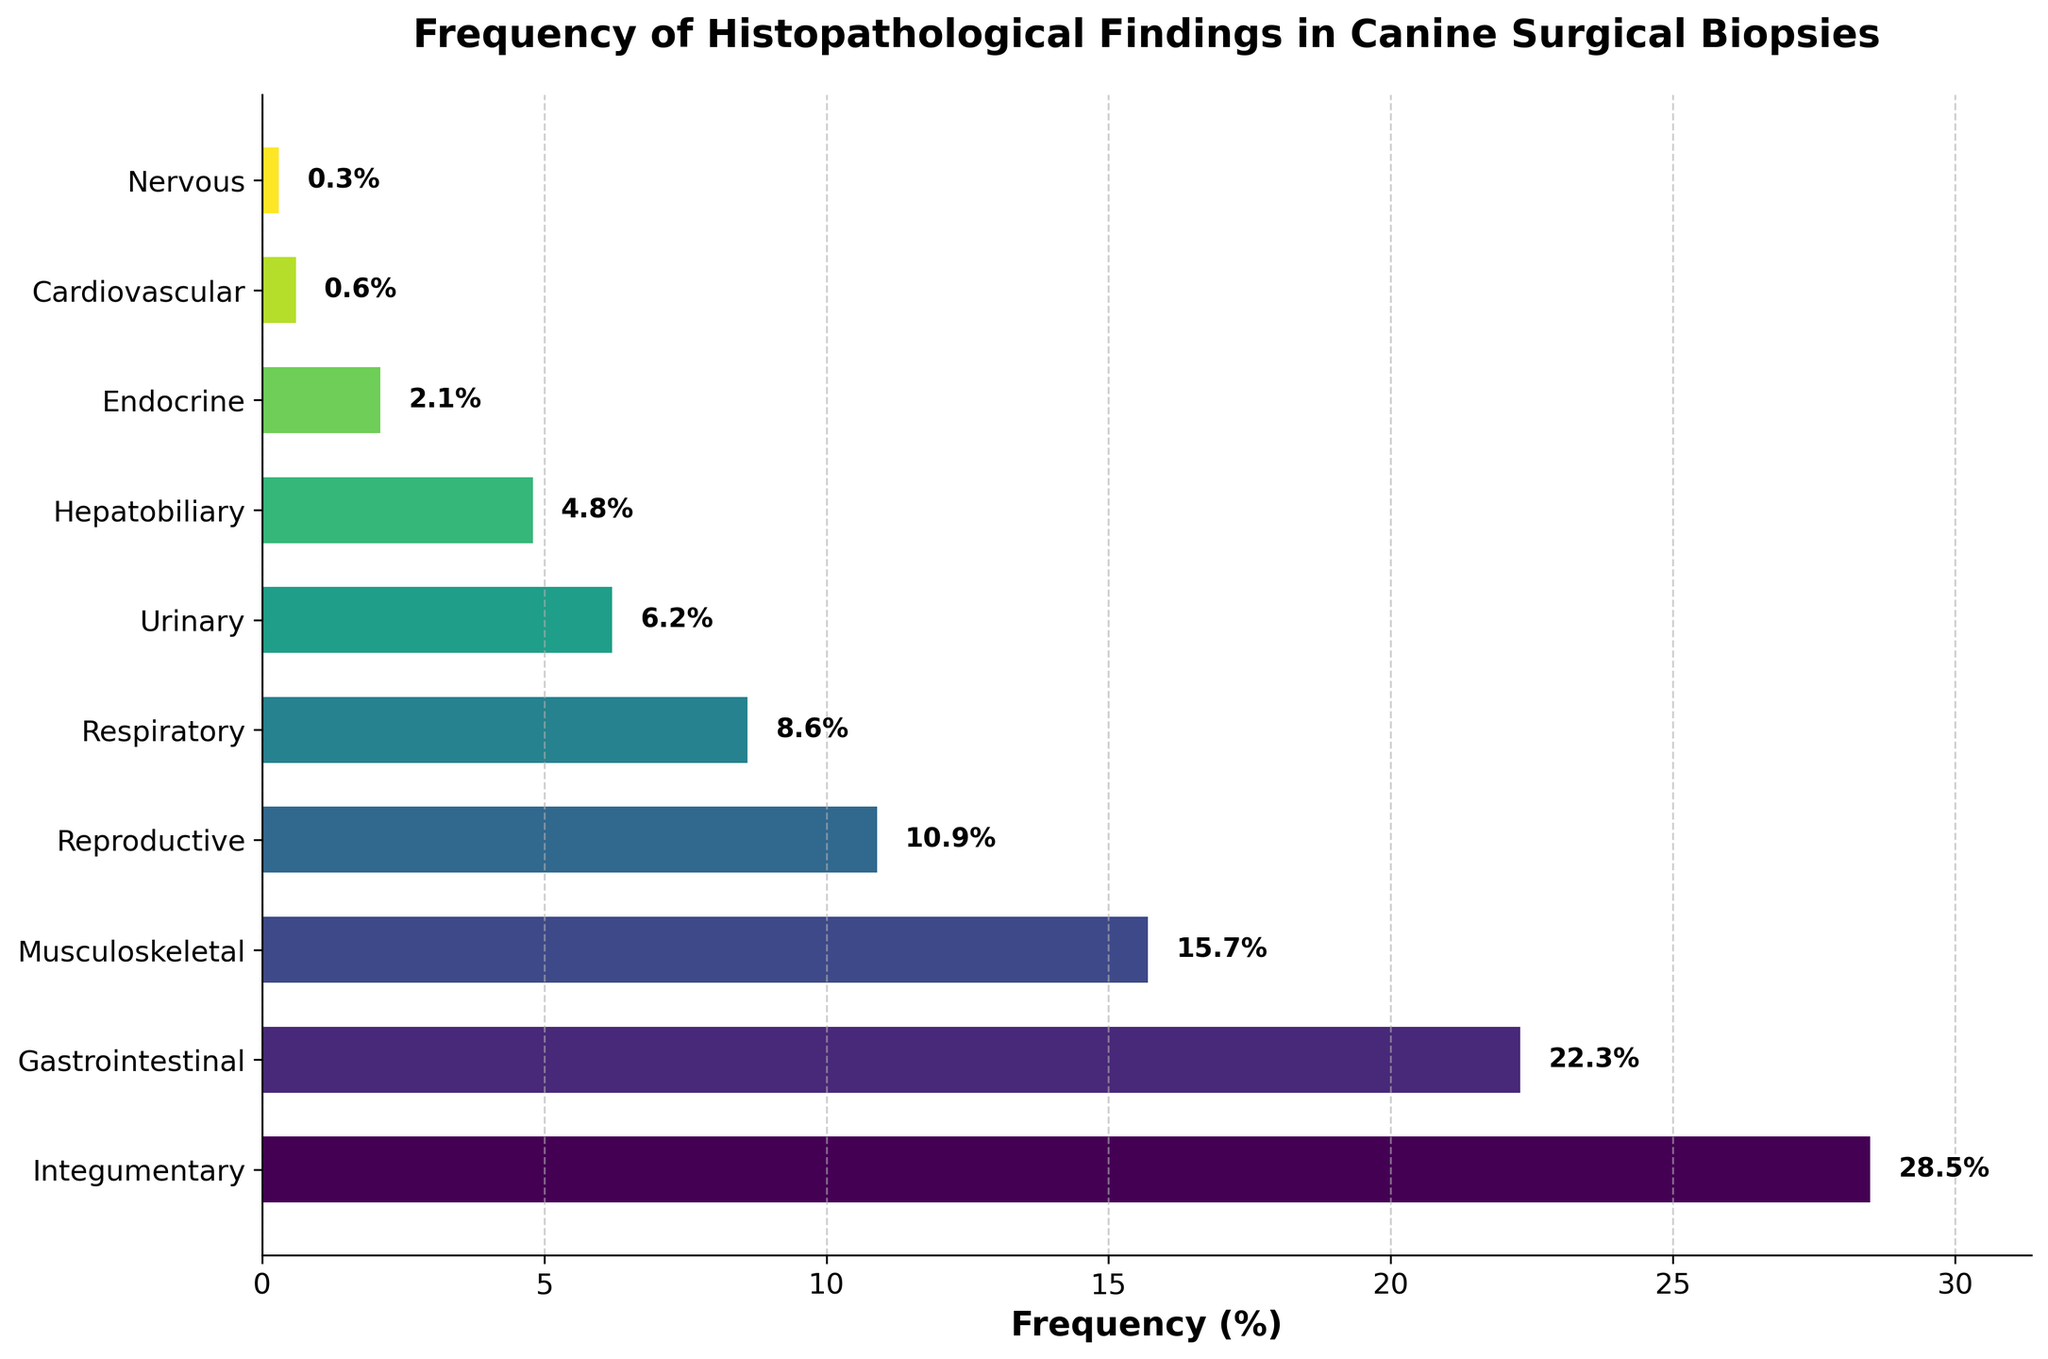What is the most frequently observed histopathological finding? The most frequently observed histopathological finding is represented by the tallest bar in the bar chart. By inspecting the bar chart, it is evident that the Integumentary system has the highest frequency at 28.5%.
Answer: Integumentary Which organ system has the lowest frequency of histopathological findings? The organ system with the lowest frequency is represented by the shortest bar in the bar chart. The Nervous system has the lowest frequency at 0.3%.
Answer: Nervous What is the cumulative frequency of the three organ systems with the lowest findings? We sum the frequencies of the three organ systems with the lowest findings. The systems and their frequencies are Nervous (0.3%), Cardiovascular (0.6%), and Endocrine (2.1%). Therefore, the cumulative frequency is 0.3% + 0.6% + 2.1% = 3.0%.
Answer: 3.0% How much higher is the frequency of the Integumentary system compared to the Urinary system? We subtract the frequency of the Urinary system from the frequency of the Integumentary system. Integumentary is 28.5% and Urinary is 6.2%, so 28.5% - 6.2% = 22.3%.
Answer: 22.3% Are there more histopathological findings in the Gastrointestinal system or the Respiratory system, and by how much? We compare the frequencies of the Gastrointestinal system (22.3%) and the Respiratory system (8.6%). Gastrointestinal has more findings, and the difference is 22.3% - 8.6% = 13.7%.
Answer: Gastrointestinal by 13.7% What is the average frequency of histopathological findings in the Musculoskeletal, Reproductive, and Respiratory systems? We calculate the average by adding the frequencies of these three systems and then dividing by three. (Musculoskeletal: 15.7%, Reproductive: 10.9%, Respiratory: 8.6%). The sum is 15.7% + 10.9% + 8.6% = 35.2%, and the average is 35.2% / 3 ≈ 11.73%.
Answer: 11.73% Which organ systems have a frequency greater than 10%? By inspecting the bar chart, the organ systems with frequencies greater than 10% are Integumentary (28.5%), Gastrointestinal (22.3%), Musculoskeletal (15.7%), and Reproductive (10.9%).
Answer: Integumentary, Gastrointestinal, Musculoskeletal, Reproductive What is the total frequency percentage for all organ systems combined? We sum the frequencies of all organ systems. The total frequency is 28.5% + 22.3% + 15.7% + 10.9% + 8.6% + 6.2% + 4.8% + 2.1% + 0.6% + 0.3% = 100%.
Answer: 100% Which organ system is directly positioned below the Gastrointestinal system based on frequency? The organ system directly below the Gastrointestinal system in terms of frequency is the Musculoskeletal system with a frequency of 15.7%.
Answer: Musculoskeletal 